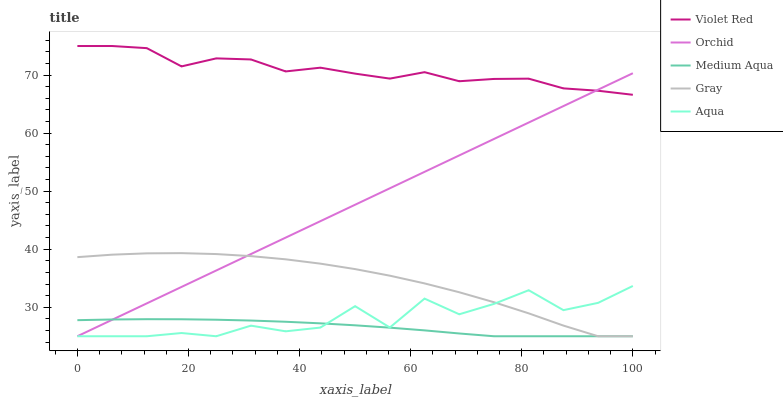Does Medium Aqua have the minimum area under the curve?
Answer yes or no. Yes. Does Violet Red have the maximum area under the curve?
Answer yes or no. Yes. Does Gray have the minimum area under the curve?
Answer yes or no. No. Does Gray have the maximum area under the curve?
Answer yes or no. No. Is Orchid the smoothest?
Answer yes or no. Yes. Is Aqua the roughest?
Answer yes or no. Yes. Is Gray the smoothest?
Answer yes or no. No. Is Gray the roughest?
Answer yes or no. No. Does Aqua have the lowest value?
Answer yes or no. Yes. Does Violet Red have the lowest value?
Answer yes or no. No. Does Violet Red have the highest value?
Answer yes or no. Yes. Does Gray have the highest value?
Answer yes or no. No. Is Aqua less than Violet Red?
Answer yes or no. Yes. Is Violet Red greater than Medium Aqua?
Answer yes or no. Yes. Does Aqua intersect Medium Aqua?
Answer yes or no. Yes. Is Aqua less than Medium Aqua?
Answer yes or no. No. Is Aqua greater than Medium Aqua?
Answer yes or no. No. Does Aqua intersect Violet Red?
Answer yes or no. No. 